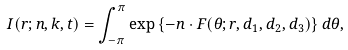<formula> <loc_0><loc_0><loc_500><loc_500>I ( r ; n , k , t ) & = \int _ { - \pi } ^ { \pi } \exp \left \{ - n \cdot F ( \theta ; r , d _ { 1 } , d _ { 2 } , d _ { 3 } ) \right \} d \theta ,</formula> 